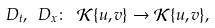<formula> <loc_0><loc_0><loc_500><loc_500>D _ { t } , \ D _ { x } \colon \ \mathcal { K } \{ u , v \} \rightarrow \mathcal { K } \{ u , v \} ,</formula> 